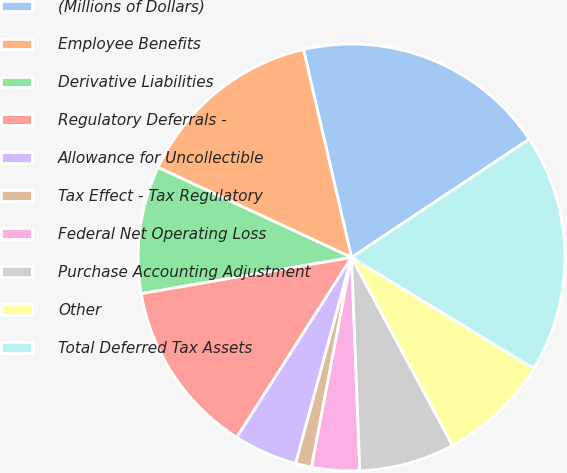Convert chart to OTSL. <chart><loc_0><loc_0><loc_500><loc_500><pie_chart><fcel>(Millions of Dollars)<fcel>Employee Benefits<fcel>Derivative Liabilities<fcel>Regulatory Deferrals -<fcel>Allowance for Uncollectible<fcel>Tax Effect - Tax Regulatory<fcel>Federal Net Operating Loss<fcel>Purchase Accounting Adjustment<fcel>Other<fcel>Total Deferred Tax Assets<nl><fcel>19.27%<fcel>14.45%<fcel>9.64%<fcel>13.25%<fcel>4.82%<fcel>1.21%<fcel>3.62%<fcel>7.23%<fcel>8.44%<fcel>18.06%<nl></chart> 